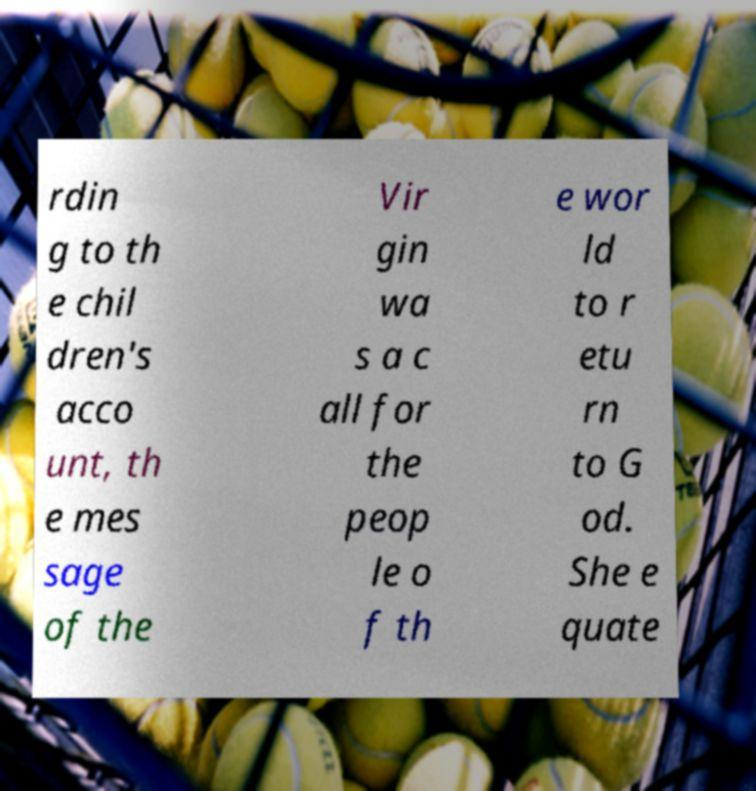Could you extract and type out the text from this image? rdin g to th e chil dren's acco unt, th e mes sage of the Vir gin wa s a c all for the peop le o f th e wor ld to r etu rn to G od. She e quate 